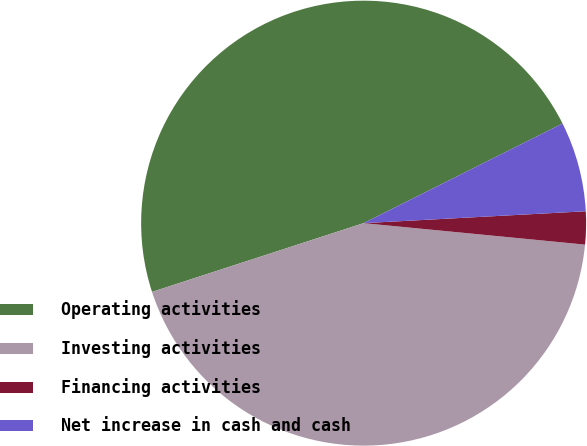Convert chart. <chart><loc_0><loc_0><loc_500><loc_500><pie_chart><fcel>Operating activities<fcel>Investing activities<fcel>Financing activities<fcel>Net increase in cash and cash<nl><fcel>47.61%<fcel>43.46%<fcel>2.39%<fcel>6.54%<nl></chart> 